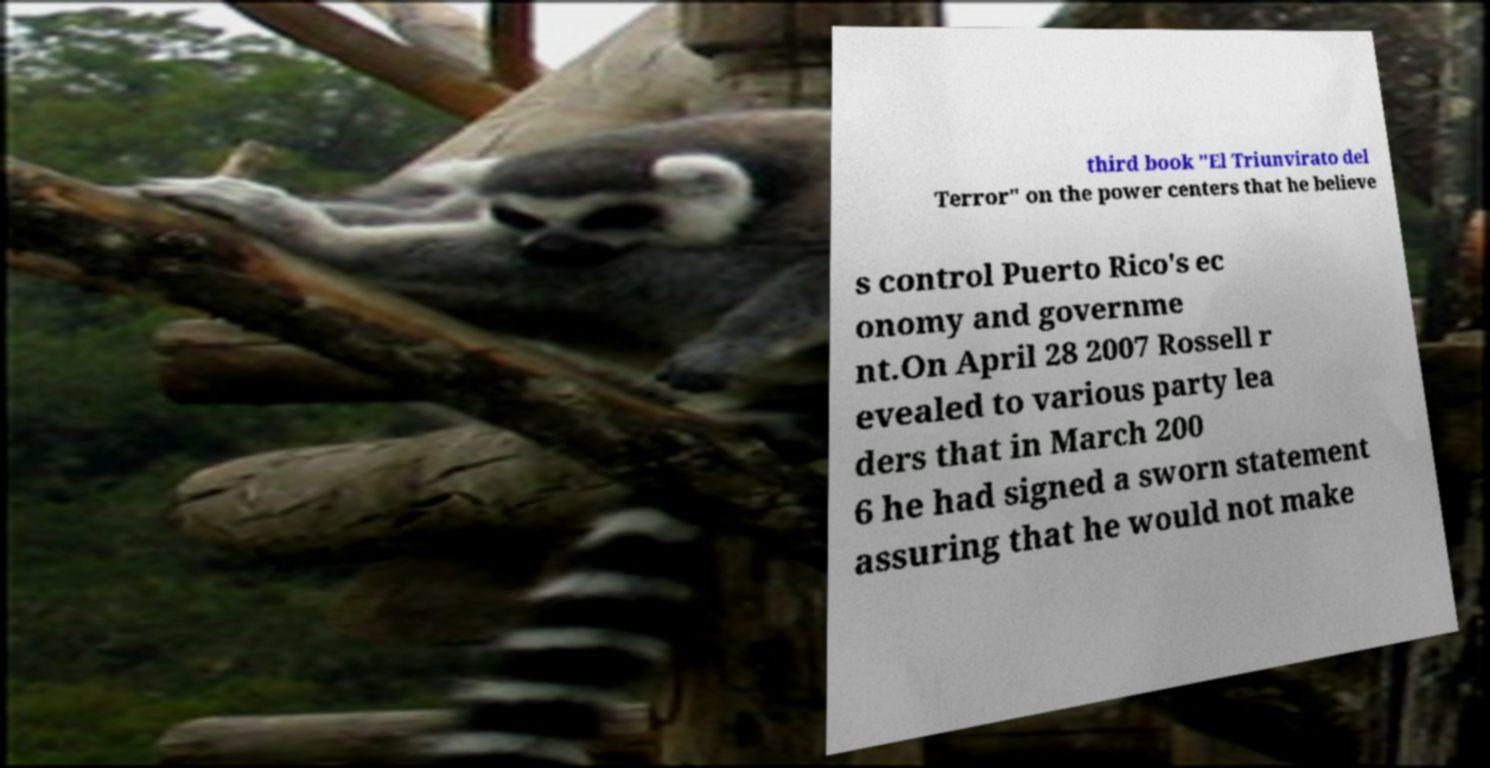Could you assist in decoding the text presented in this image and type it out clearly? third book "El Triunvirato del Terror" on the power centers that he believe s control Puerto Rico's ec onomy and governme nt.On April 28 2007 Rossell r evealed to various party lea ders that in March 200 6 he had signed a sworn statement assuring that he would not make 